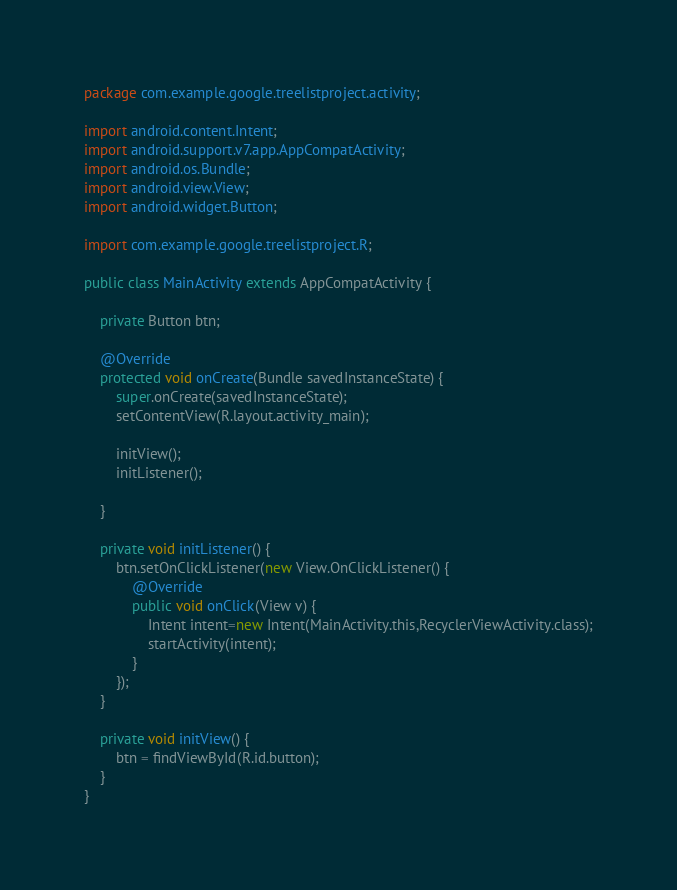Convert code to text. <code><loc_0><loc_0><loc_500><loc_500><_Java_>package com.example.google.treelistproject.activity;

import android.content.Intent;
import android.support.v7.app.AppCompatActivity;
import android.os.Bundle;
import android.view.View;
import android.widget.Button;

import com.example.google.treelistproject.R;

public class MainActivity extends AppCompatActivity {

    private Button btn;

    @Override
    protected void onCreate(Bundle savedInstanceState) {
        super.onCreate(savedInstanceState);
        setContentView(R.layout.activity_main);

        initView();
        initListener();

    }

    private void initListener() {
        btn.setOnClickListener(new View.OnClickListener() {
            @Override
            public void onClick(View v) {
                Intent intent=new Intent(MainActivity.this,RecyclerViewActivity.class);
                startActivity(intent);
            }
        });
    }

    private void initView() {
        btn = findViewById(R.id.button);
    }
}
</code> 